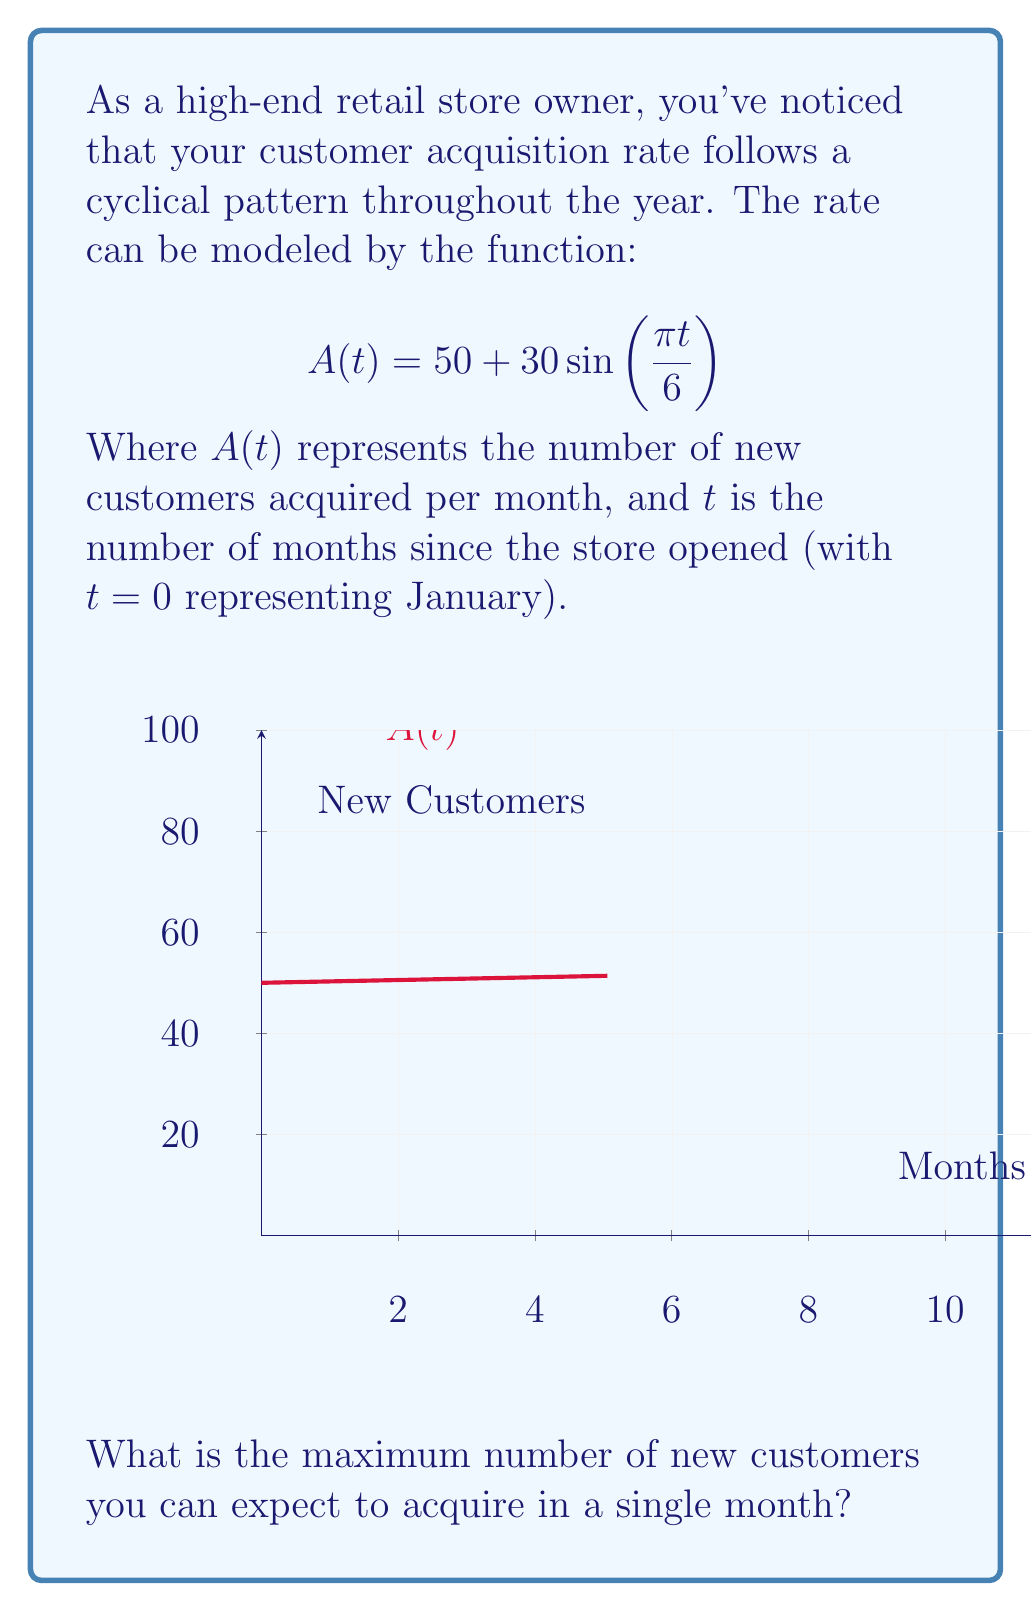What is the answer to this math problem? To find the maximum number of new customers, we need to determine the maximum value of the function $A(t)$.

1) The sine function oscillates between -1 and 1, so $\sin\left(\frac{\pi t}{6}\right)$ will oscillate between -1 and 1.

2) In the given function, $30\sin\left(\frac{\pi t}{6}\right)$ will oscillate between -30 and 30.

3) The function $A(t)$ is a vertical shift of this sine function by 50 units:
   $$A(t) = 50 + 30\sin\left(\frac{\pi t}{6}\right)$$

4) Therefore, the maximum value will occur when $\sin\left(\frac{\pi t}{6}\right) = 1$, giving:
   $$A_{max} = 50 + 30(1) = 50 + 30 = 80$$

Thus, the maximum number of new customers acquired in a single month will be 80.
Answer: 80 customers 